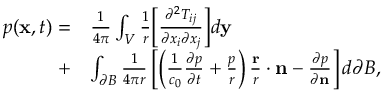Convert formula to latex. <formula><loc_0><loc_0><loc_500><loc_500>\begin{array} { r l } { p ( x , t ) = } & { \frac { 1 } { 4 \pi } \int _ { V } \frac { 1 } { r } \left [ \frac { \partial ^ { 2 } T _ { i j } } { \partial x _ { i } \partial x _ { j } } \right ] d y } \\ { + } & { \int _ { \partial B } \frac { 1 } { 4 \pi r } \left [ \left ( \frac { 1 } { c _ { 0 } } \frac { \partial p } { \partial t } + \frac { p } { r } \right ) \frac { r } { r } \cdot n - \frac { \partial p } { \partial n } \right ] d \partial B , } \end{array}</formula> 